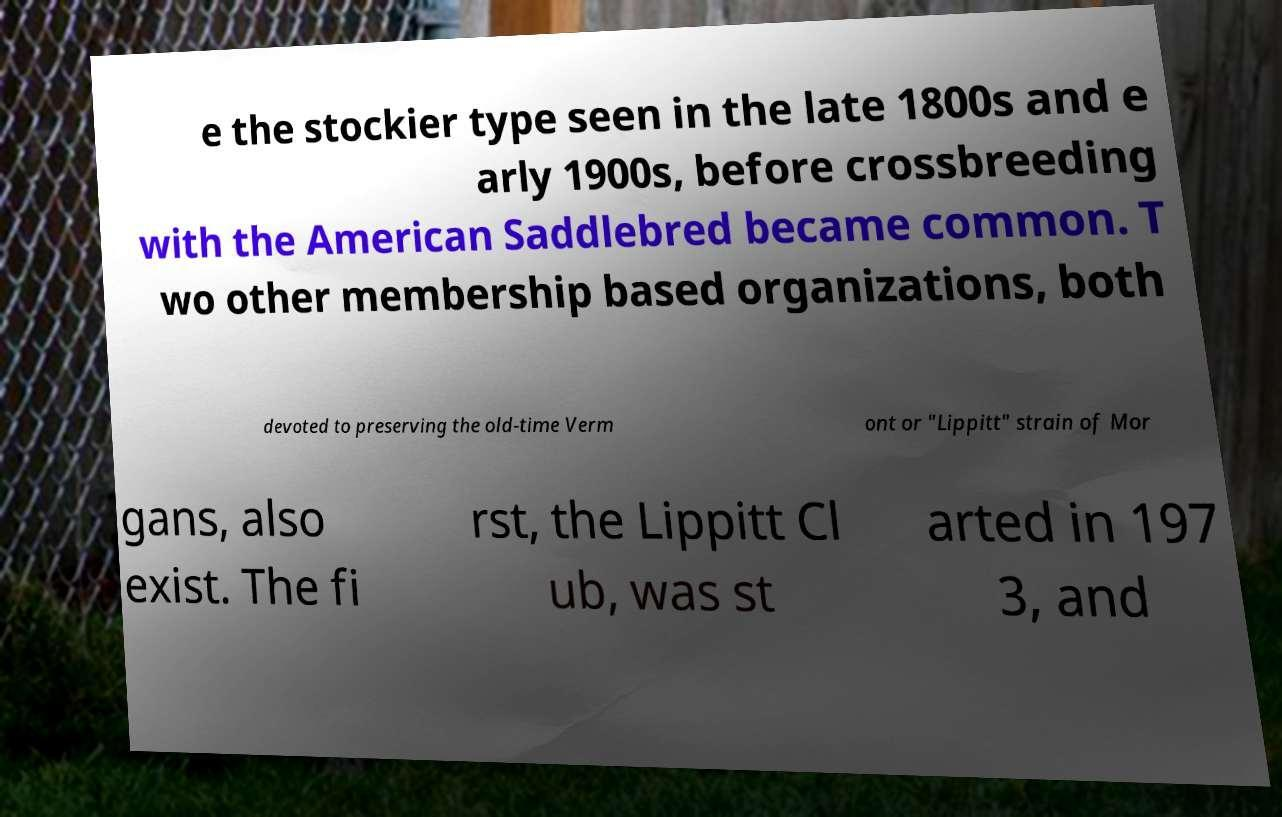There's text embedded in this image that I need extracted. Can you transcribe it verbatim? e the stockier type seen in the late 1800s and e arly 1900s, before crossbreeding with the American Saddlebred became common. T wo other membership based organizations, both devoted to preserving the old-time Verm ont or "Lippitt" strain of Mor gans, also exist. The fi rst, the Lippitt Cl ub, was st arted in 197 3, and 